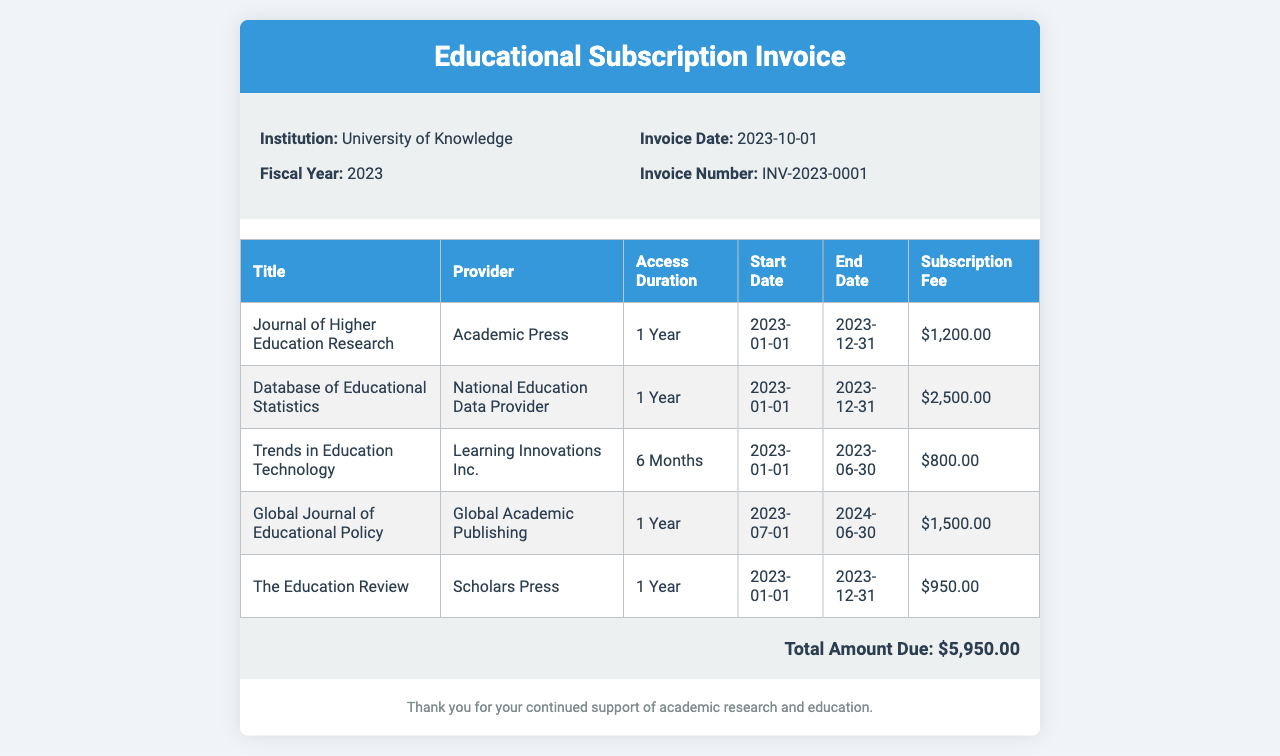What is the institution name? The institution name is listed at the top of the document under the institution section.
Answer: University of Knowledge What is the total amount due? The total amount due is stated at the bottom of the invoice.
Answer: $5,950.00 Who is the provider for the "Database of Educational Statistics"? The provider is mentioned in the corresponding row of the subscription table.
Answer: National Education Data Provider What is the access duration for "Trends in Education Technology"? The access duration is specified within its row in the subscription table.
Answer: 6 Months What is the invoice date? The invoice date is given in the details section of the invoice.
Answer: 2023-10-01 How many subscriptions have a duration of 1 Year? The number of subscriptions can be counted in the subscription table under access duration.
Answer: 4 What is the start date for the "Global Journal of Educational Policy"? The start date is indicated in the subscription table for that title.
Answer: 2023-07-01 Which title has the highest subscription fee? The highest subscription fee can be determined by comparing the fees listed in the last column of the table.
Answer: Database of Educational Statistics What is the invoice number? The invoice number is stated in the details section of the invoice.
Answer: INV-2023-0001 